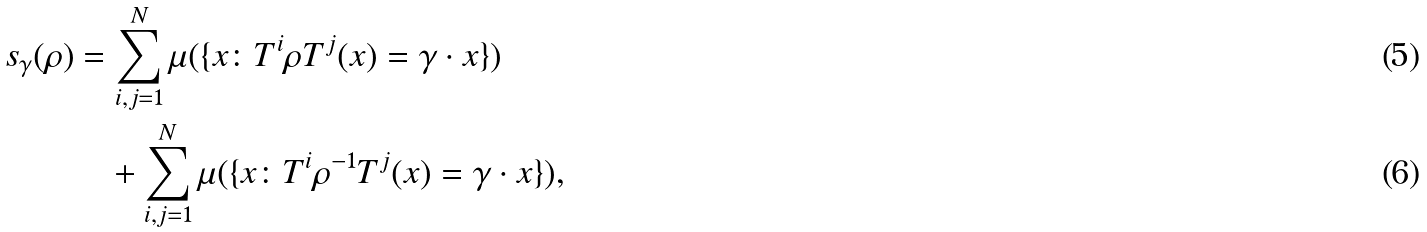Convert formula to latex. <formula><loc_0><loc_0><loc_500><loc_500>s _ { \gamma } ( \rho ) & = \sum ^ { N } _ { i , j = 1 } \mu ( \{ x \colon T ^ { i } \rho T ^ { j } ( x ) = \gamma \cdot x \} ) \\ & \quad + \sum ^ { N } _ { i , j = 1 } \mu ( \{ x \colon T ^ { i } \rho ^ { - 1 } T ^ { j } ( x ) = \gamma \cdot x \} ) ,</formula> 